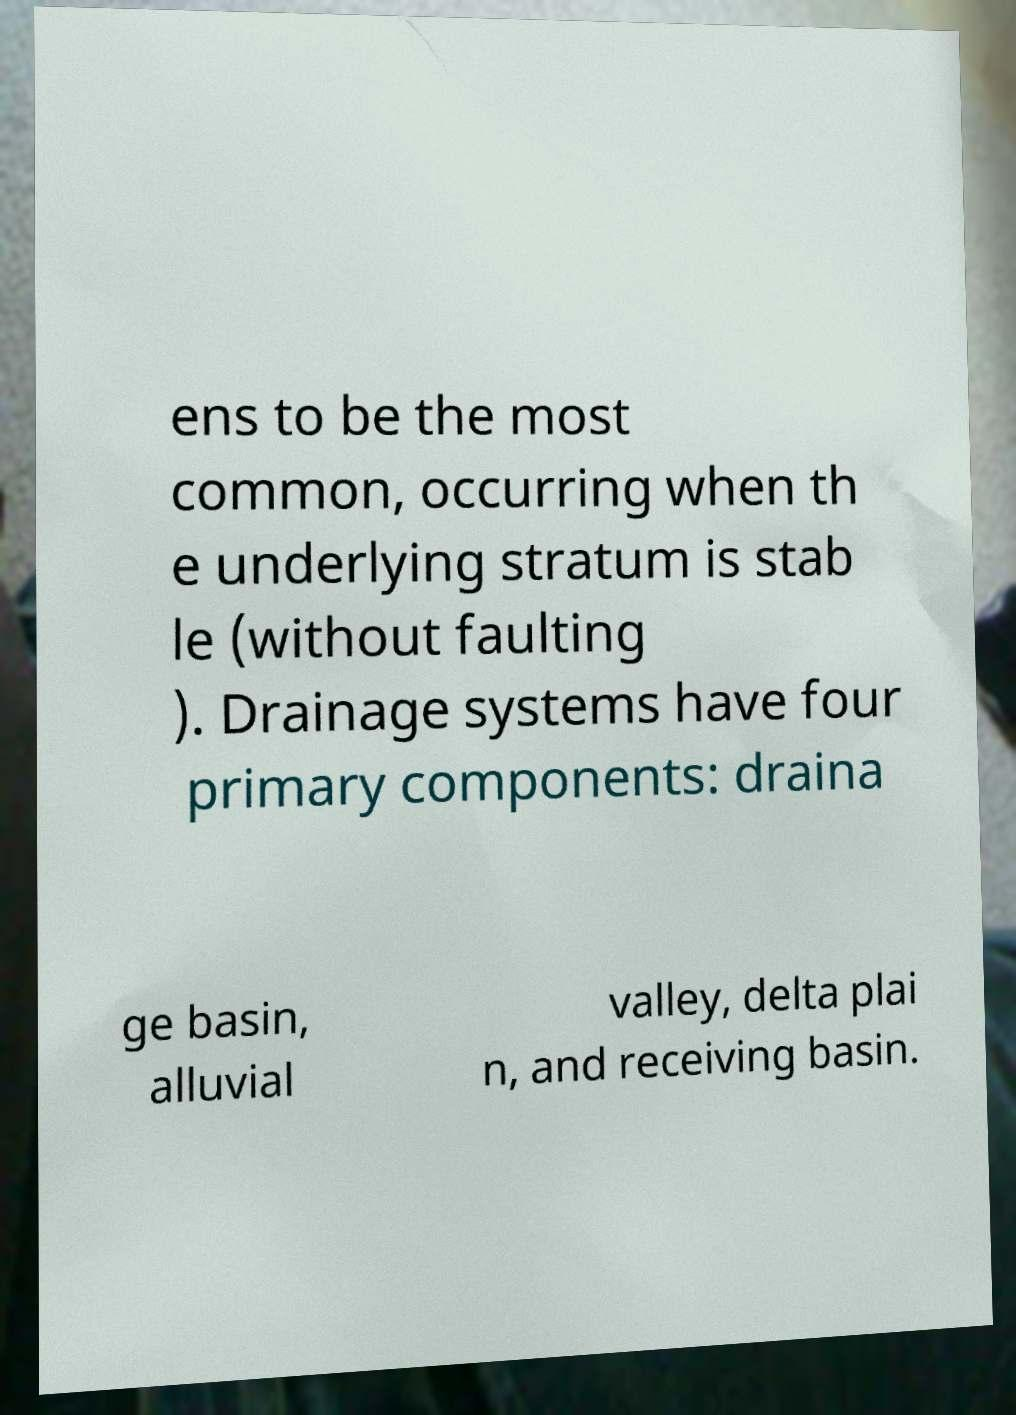Please read and relay the text visible in this image. What does it say? ens to be the most common, occurring when th e underlying stratum is stab le (without faulting ). Drainage systems have four primary components: draina ge basin, alluvial valley, delta plai n, and receiving basin. 